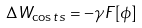Convert formula to latex. <formula><loc_0><loc_0><loc_500><loc_500>\Delta W _ { \cos t s } = - \gamma F [ \phi ]</formula> 